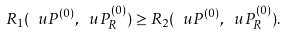<formula> <loc_0><loc_0><loc_500><loc_500>R _ { 1 } ( \ u P ^ { ( 0 ) } , \ u P _ { R } ^ { ( 0 ) } ) \geq R _ { 2 } ( \ u P ^ { ( 0 ) } , \ u P _ { R } ^ { ( 0 ) } ) .</formula> 